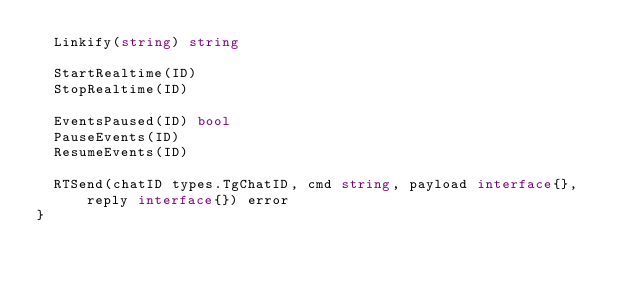Convert code to text. <code><loc_0><loc_0><loc_500><loc_500><_Go_>	Linkify(string) string

	StartRealtime(ID)
	StopRealtime(ID)

	EventsPaused(ID) bool
	PauseEvents(ID)
	ResumeEvents(ID)

	RTSend(chatID types.TgChatID, cmd string, payload interface{}, reply interface{}) error
}
</code> 